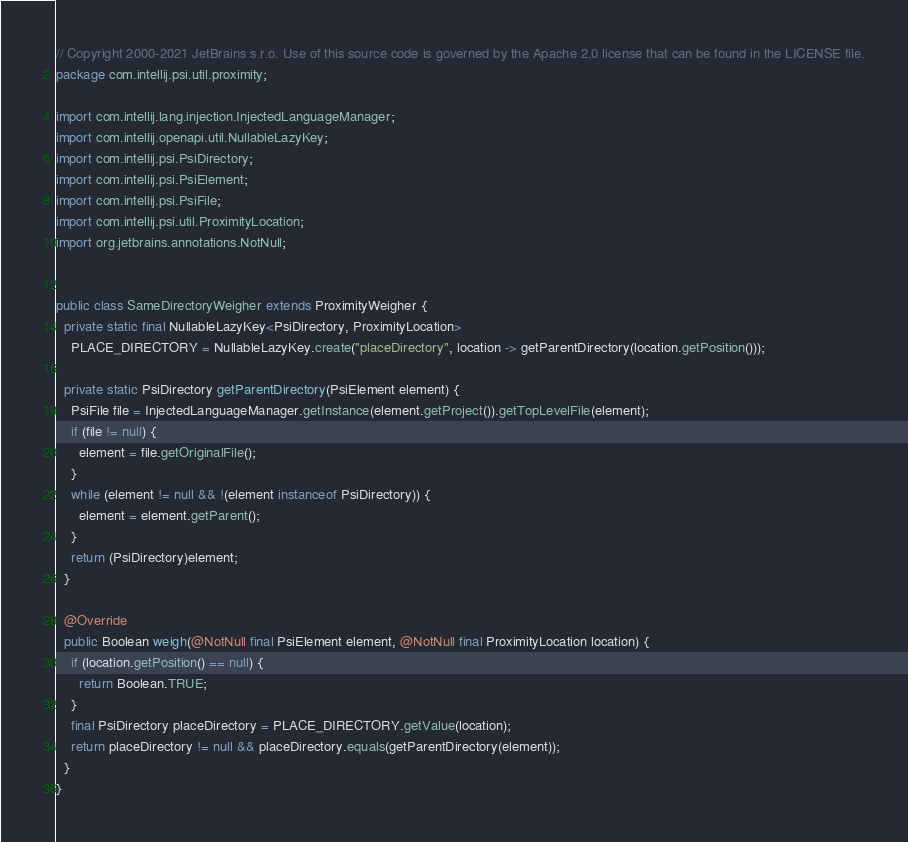Convert code to text. <code><loc_0><loc_0><loc_500><loc_500><_Java_>// Copyright 2000-2021 JetBrains s.r.o. Use of this source code is governed by the Apache 2.0 license that can be found in the LICENSE file.
package com.intellij.psi.util.proximity;

import com.intellij.lang.injection.InjectedLanguageManager;
import com.intellij.openapi.util.NullableLazyKey;
import com.intellij.psi.PsiDirectory;
import com.intellij.psi.PsiElement;
import com.intellij.psi.PsiFile;
import com.intellij.psi.util.ProximityLocation;
import org.jetbrains.annotations.NotNull;


public class SameDirectoryWeigher extends ProximityWeigher {
  private static final NullableLazyKey<PsiDirectory, ProximityLocation>
    PLACE_DIRECTORY = NullableLazyKey.create("placeDirectory", location -> getParentDirectory(location.getPosition()));

  private static PsiDirectory getParentDirectory(PsiElement element) {
    PsiFile file = InjectedLanguageManager.getInstance(element.getProject()).getTopLevelFile(element);
    if (file != null) {
      element = file.getOriginalFile();
    }
    while (element != null && !(element instanceof PsiDirectory)) {
      element = element.getParent();
    }
    return (PsiDirectory)element;
  }

  @Override
  public Boolean weigh(@NotNull final PsiElement element, @NotNull final ProximityLocation location) {
    if (location.getPosition() == null) {
      return Boolean.TRUE;
    }
    final PsiDirectory placeDirectory = PLACE_DIRECTORY.getValue(location);
    return placeDirectory != null && placeDirectory.equals(getParentDirectory(element));
  }
}
</code> 